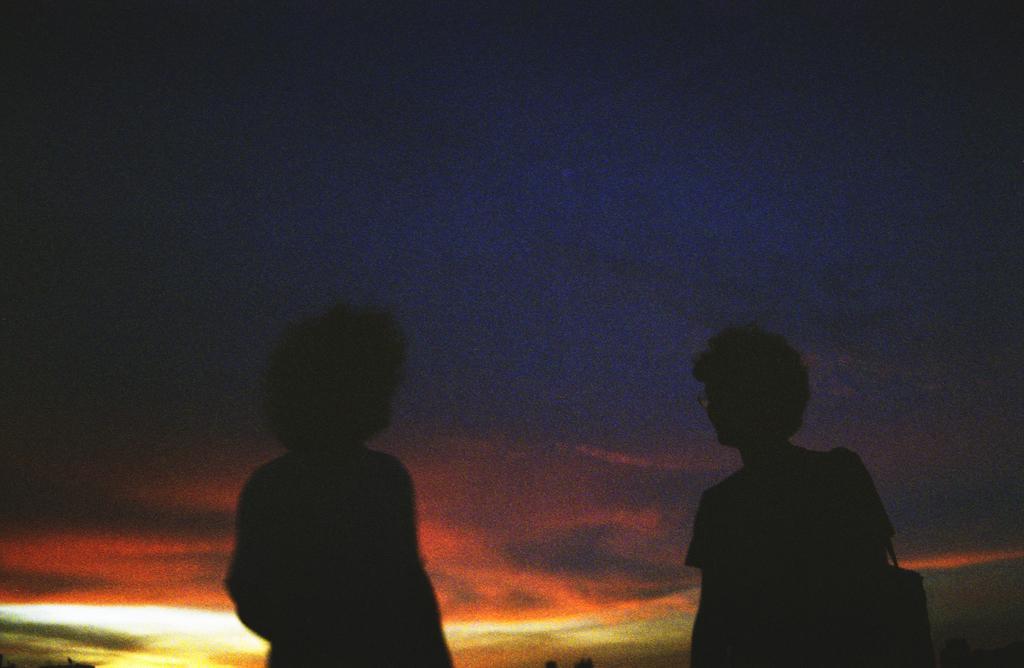Can you describe this image briefly? Here we can see two persons. In the background there is sky and it is dark. 